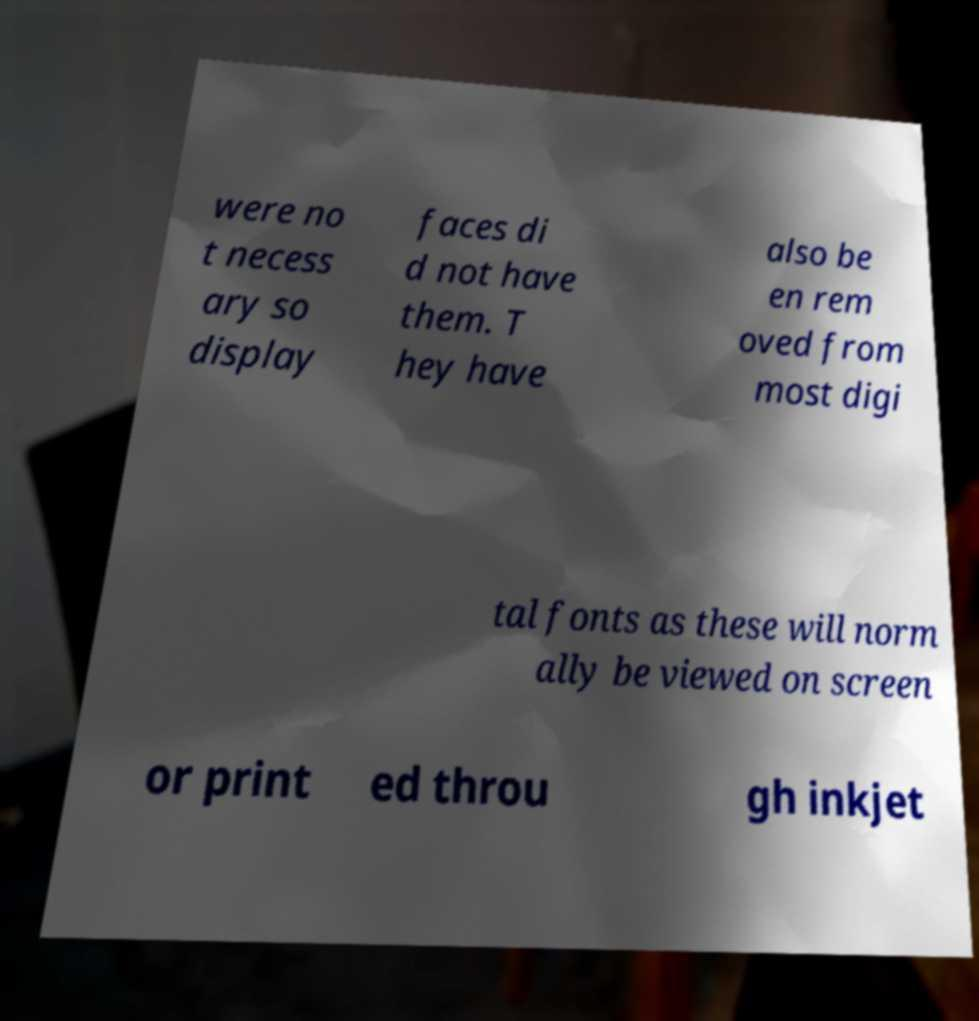Please read and relay the text visible in this image. What does it say? were no t necess ary so display faces di d not have them. T hey have also be en rem oved from most digi tal fonts as these will norm ally be viewed on screen or print ed throu gh inkjet 